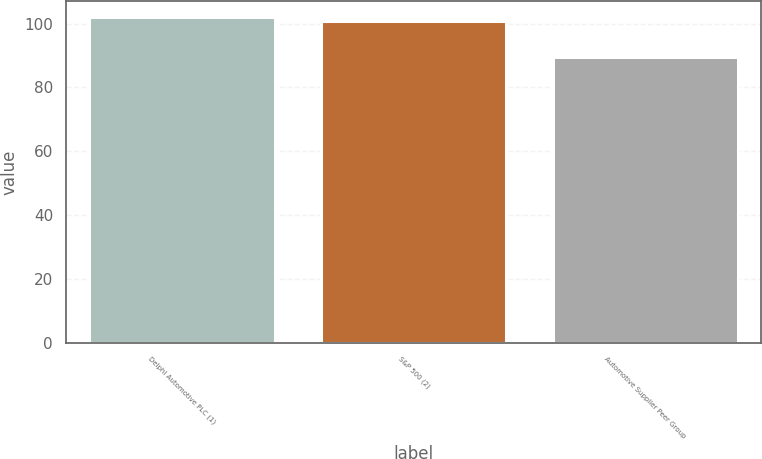Convert chart to OTSL. <chart><loc_0><loc_0><loc_500><loc_500><bar_chart><fcel>Delphi Automotive PLC (1)<fcel>S&P 500 (2)<fcel>Automotive Supplier Peer Group<nl><fcel>101.94<fcel>100.8<fcel>89.62<nl></chart> 